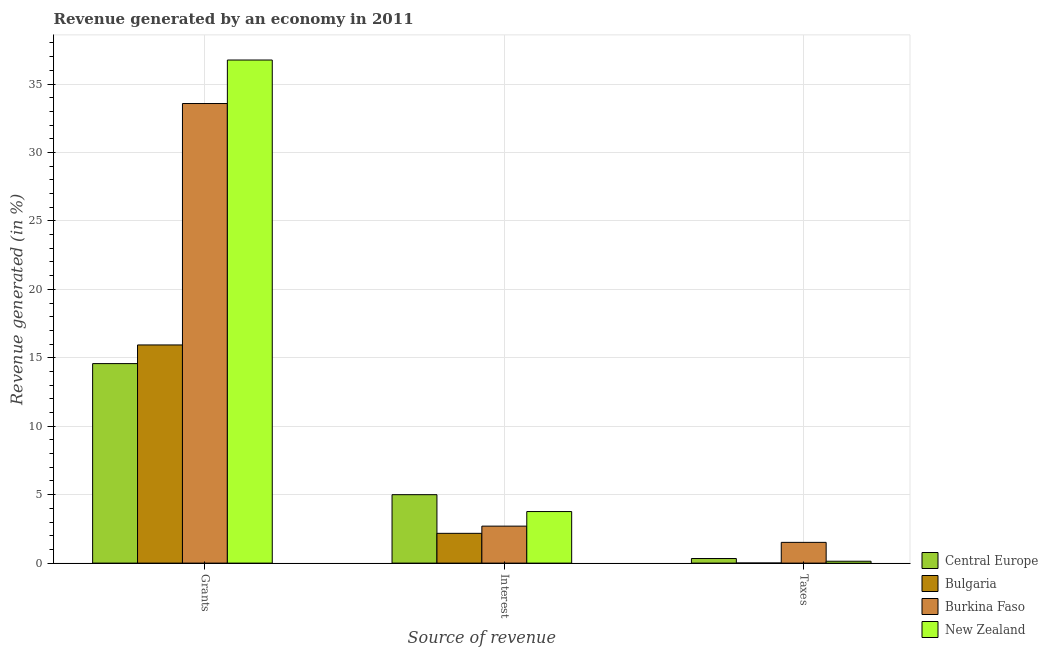How many different coloured bars are there?
Your answer should be very brief. 4. Are the number of bars per tick equal to the number of legend labels?
Your answer should be very brief. Yes. How many bars are there on the 2nd tick from the right?
Provide a short and direct response. 4. What is the label of the 2nd group of bars from the left?
Your answer should be compact. Interest. What is the percentage of revenue generated by interest in Burkina Faso?
Keep it short and to the point. 2.7. Across all countries, what is the maximum percentage of revenue generated by taxes?
Offer a very short reply. 1.52. Across all countries, what is the minimum percentage of revenue generated by grants?
Provide a short and direct response. 14.58. In which country was the percentage of revenue generated by grants maximum?
Your answer should be compact. New Zealand. In which country was the percentage of revenue generated by grants minimum?
Keep it short and to the point. Central Europe. What is the total percentage of revenue generated by grants in the graph?
Keep it short and to the point. 100.85. What is the difference between the percentage of revenue generated by interest in New Zealand and that in Central Europe?
Provide a short and direct response. -1.23. What is the difference between the percentage of revenue generated by grants in Burkina Faso and the percentage of revenue generated by interest in Central Europe?
Ensure brevity in your answer.  28.58. What is the average percentage of revenue generated by grants per country?
Offer a terse response. 25.21. What is the difference between the percentage of revenue generated by taxes and percentage of revenue generated by grants in Central Europe?
Your response must be concise. -14.24. In how many countries, is the percentage of revenue generated by grants greater than 16 %?
Keep it short and to the point. 2. What is the ratio of the percentage of revenue generated by grants in Central Europe to that in Burkina Faso?
Keep it short and to the point. 0.43. What is the difference between the highest and the second highest percentage of revenue generated by grants?
Offer a terse response. 3.18. What is the difference between the highest and the lowest percentage of revenue generated by grants?
Your answer should be compact. 22.18. Is the sum of the percentage of revenue generated by interest in New Zealand and Burkina Faso greater than the maximum percentage of revenue generated by grants across all countries?
Offer a terse response. No. What does the 2nd bar from the left in Interest represents?
Offer a very short reply. Bulgaria. What does the 1st bar from the right in Grants represents?
Your response must be concise. New Zealand. Is it the case that in every country, the sum of the percentage of revenue generated by grants and percentage of revenue generated by interest is greater than the percentage of revenue generated by taxes?
Make the answer very short. Yes. How many bars are there?
Ensure brevity in your answer.  12. Are all the bars in the graph horizontal?
Make the answer very short. No. How many countries are there in the graph?
Make the answer very short. 4. What is the difference between two consecutive major ticks on the Y-axis?
Your response must be concise. 5. Does the graph contain any zero values?
Your answer should be compact. No. Where does the legend appear in the graph?
Offer a very short reply. Bottom right. How are the legend labels stacked?
Keep it short and to the point. Vertical. What is the title of the graph?
Make the answer very short. Revenue generated by an economy in 2011. Does "High income: OECD" appear as one of the legend labels in the graph?
Offer a terse response. No. What is the label or title of the X-axis?
Make the answer very short. Source of revenue. What is the label or title of the Y-axis?
Your answer should be very brief. Revenue generated (in %). What is the Revenue generated (in %) of Central Europe in Grants?
Your answer should be very brief. 14.58. What is the Revenue generated (in %) of Bulgaria in Grants?
Make the answer very short. 15.94. What is the Revenue generated (in %) in Burkina Faso in Grants?
Your answer should be compact. 33.58. What is the Revenue generated (in %) in New Zealand in Grants?
Keep it short and to the point. 36.76. What is the Revenue generated (in %) of Central Europe in Interest?
Your answer should be compact. 5. What is the Revenue generated (in %) of Bulgaria in Interest?
Ensure brevity in your answer.  2.18. What is the Revenue generated (in %) in Burkina Faso in Interest?
Provide a short and direct response. 2.7. What is the Revenue generated (in %) of New Zealand in Interest?
Your answer should be very brief. 3.77. What is the Revenue generated (in %) in Central Europe in Taxes?
Provide a succinct answer. 0.34. What is the Revenue generated (in %) of Bulgaria in Taxes?
Provide a short and direct response. 0.01. What is the Revenue generated (in %) of Burkina Faso in Taxes?
Your answer should be compact. 1.52. What is the Revenue generated (in %) in New Zealand in Taxes?
Your response must be concise. 0.14. Across all Source of revenue, what is the maximum Revenue generated (in %) in Central Europe?
Your answer should be compact. 14.58. Across all Source of revenue, what is the maximum Revenue generated (in %) of Bulgaria?
Make the answer very short. 15.94. Across all Source of revenue, what is the maximum Revenue generated (in %) of Burkina Faso?
Ensure brevity in your answer.  33.58. Across all Source of revenue, what is the maximum Revenue generated (in %) of New Zealand?
Provide a short and direct response. 36.76. Across all Source of revenue, what is the minimum Revenue generated (in %) of Central Europe?
Provide a succinct answer. 0.34. Across all Source of revenue, what is the minimum Revenue generated (in %) in Bulgaria?
Keep it short and to the point. 0.01. Across all Source of revenue, what is the minimum Revenue generated (in %) of Burkina Faso?
Provide a short and direct response. 1.52. Across all Source of revenue, what is the minimum Revenue generated (in %) in New Zealand?
Offer a terse response. 0.14. What is the total Revenue generated (in %) in Central Europe in the graph?
Give a very brief answer. 19.91. What is the total Revenue generated (in %) in Bulgaria in the graph?
Your answer should be very brief. 18.12. What is the total Revenue generated (in %) in Burkina Faso in the graph?
Offer a terse response. 37.79. What is the total Revenue generated (in %) in New Zealand in the graph?
Make the answer very short. 40.66. What is the difference between the Revenue generated (in %) of Central Europe in Grants and that in Interest?
Give a very brief answer. 9.58. What is the difference between the Revenue generated (in %) of Bulgaria in Grants and that in Interest?
Offer a terse response. 13.76. What is the difference between the Revenue generated (in %) in Burkina Faso in Grants and that in Interest?
Provide a succinct answer. 30.88. What is the difference between the Revenue generated (in %) in New Zealand in Grants and that in Interest?
Offer a terse response. 32.99. What is the difference between the Revenue generated (in %) of Central Europe in Grants and that in Taxes?
Keep it short and to the point. 14.24. What is the difference between the Revenue generated (in %) of Bulgaria in Grants and that in Taxes?
Your answer should be compact. 15.93. What is the difference between the Revenue generated (in %) of Burkina Faso in Grants and that in Taxes?
Provide a succinct answer. 32.06. What is the difference between the Revenue generated (in %) in New Zealand in Grants and that in Taxes?
Your response must be concise. 36.62. What is the difference between the Revenue generated (in %) in Central Europe in Interest and that in Taxes?
Provide a short and direct response. 4.66. What is the difference between the Revenue generated (in %) in Bulgaria in Interest and that in Taxes?
Your answer should be very brief. 2.17. What is the difference between the Revenue generated (in %) in Burkina Faso in Interest and that in Taxes?
Offer a very short reply. 1.19. What is the difference between the Revenue generated (in %) in New Zealand in Interest and that in Taxes?
Your answer should be compact. 3.63. What is the difference between the Revenue generated (in %) in Central Europe in Grants and the Revenue generated (in %) in Bulgaria in Interest?
Your answer should be very brief. 12.4. What is the difference between the Revenue generated (in %) in Central Europe in Grants and the Revenue generated (in %) in Burkina Faso in Interest?
Keep it short and to the point. 11.88. What is the difference between the Revenue generated (in %) in Central Europe in Grants and the Revenue generated (in %) in New Zealand in Interest?
Provide a succinct answer. 10.81. What is the difference between the Revenue generated (in %) of Bulgaria in Grants and the Revenue generated (in %) of Burkina Faso in Interest?
Ensure brevity in your answer.  13.24. What is the difference between the Revenue generated (in %) in Bulgaria in Grants and the Revenue generated (in %) in New Zealand in Interest?
Make the answer very short. 12.17. What is the difference between the Revenue generated (in %) in Burkina Faso in Grants and the Revenue generated (in %) in New Zealand in Interest?
Your answer should be very brief. 29.81. What is the difference between the Revenue generated (in %) in Central Europe in Grants and the Revenue generated (in %) in Bulgaria in Taxes?
Make the answer very short. 14.57. What is the difference between the Revenue generated (in %) in Central Europe in Grants and the Revenue generated (in %) in Burkina Faso in Taxes?
Your answer should be very brief. 13.06. What is the difference between the Revenue generated (in %) in Central Europe in Grants and the Revenue generated (in %) in New Zealand in Taxes?
Provide a short and direct response. 14.44. What is the difference between the Revenue generated (in %) of Bulgaria in Grants and the Revenue generated (in %) of Burkina Faso in Taxes?
Provide a short and direct response. 14.42. What is the difference between the Revenue generated (in %) of Bulgaria in Grants and the Revenue generated (in %) of New Zealand in Taxes?
Your answer should be very brief. 15.8. What is the difference between the Revenue generated (in %) in Burkina Faso in Grants and the Revenue generated (in %) in New Zealand in Taxes?
Keep it short and to the point. 33.44. What is the difference between the Revenue generated (in %) in Central Europe in Interest and the Revenue generated (in %) in Bulgaria in Taxes?
Your answer should be very brief. 4.99. What is the difference between the Revenue generated (in %) in Central Europe in Interest and the Revenue generated (in %) in Burkina Faso in Taxes?
Offer a terse response. 3.48. What is the difference between the Revenue generated (in %) in Central Europe in Interest and the Revenue generated (in %) in New Zealand in Taxes?
Your response must be concise. 4.86. What is the difference between the Revenue generated (in %) in Bulgaria in Interest and the Revenue generated (in %) in Burkina Faso in Taxes?
Your response must be concise. 0.66. What is the difference between the Revenue generated (in %) in Bulgaria in Interest and the Revenue generated (in %) in New Zealand in Taxes?
Ensure brevity in your answer.  2.04. What is the difference between the Revenue generated (in %) of Burkina Faso in Interest and the Revenue generated (in %) of New Zealand in Taxes?
Give a very brief answer. 2.56. What is the average Revenue generated (in %) in Central Europe per Source of revenue?
Offer a terse response. 6.64. What is the average Revenue generated (in %) of Bulgaria per Source of revenue?
Provide a succinct answer. 6.04. What is the average Revenue generated (in %) of Burkina Faso per Source of revenue?
Provide a short and direct response. 12.6. What is the average Revenue generated (in %) of New Zealand per Source of revenue?
Your answer should be very brief. 13.55. What is the difference between the Revenue generated (in %) in Central Europe and Revenue generated (in %) in Bulgaria in Grants?
Make the answer very short. -1.36. What is the difference between the Revenue generated (in %) in Central Europe and Revenue generated (in %) in Burkina Faso in Grants?
Offer a terse response. -19. What is the difference between the Revenue generated (in %) of Central Europe and Revenue generated (in %) of New Zealand in Grants?
Your response must be concise. -22.18. What is the difference between the Revenue generated (in %) of Bulgaria and Revenue generated (in %) of Burkina Faso in Grants?
Your response must be concise. -17.64. What is the difference between the Revenue generated (in %) in Bulgaria and Revenue generated (in %) in New Zealand in Grants?
Offer a very short reply. -20.82. What is the difference between the Revenue generated (in %) of Burkina Faso and Revenue generated (in %) of New Zealand in Grants?
Give a very brief answer. -3.18. What is the difference between the Revenue generated (in %) in Central Europe and Revenue generated (in %) in Bulgaria in Interest?
Give a very brief answer. 2.82. What is the difference between the Revenue generated (in %) in Central Europe and Revenue generated (in %) in Burkina Faso in Interest?
Keep it short and to the point. 2.3. What is the difference between the Revenue generated (in %) in Central Europe and Revenue generated (in %) in New Zealand in Interest?
Provide a short and direct response. 1.23. What is the difference between the Revenue generated (in %) of Bulgaria and Revenue generated (in %) of Burkina Faso in Interest?
Make the answer very short. -0.53. What is the difference between the Revenue generated (in %) of Bulgaria and Revenue generated (in %) of New Zealand in Interest?
Offer a terse response. -1.59. What is the difference between the Revenue generated (in %) of Burkina Faso and Revenue generated (in %) of New Zealand in Interest?
Your response must be concise. -1.07. What is the difference between the Revenue generated (in %) of Central Europe and Revenue generated (in %) of Bulgaria in Taxes?
Give a very brief answer. 0.33. What is the difference between the Revenue generated (in %) of Central Europe and Revenue generated (in %) of Burkina Faso in Taxes?
Provide a short and direct response. -1.18. What is the difference between the Revenue generated (in %) of Central Europe and Revenue generated (in %) of New Zealand in Taxes?
Provide a succinct answer. 0.2. What is the difference between the Revenue generated (in %) of Bulgaria and Revenue generated (in %) of Burkina Faso in Taxes?
Offer a very short reply. -1.51. What is the difference between the Revenue generated (in %) in Bulgaria and Revenue generated (in %) in New Zealand in Taxes?
Give a very brief answer. -0.13. What is the difference between the Revenue generated (in %) in Burkina Faso and Revenue generated (in %) in New Zealand in Taxes?
Keep it short and to the point. 1.38. What is the ratio of the Revenue generated (in %) of Central Europe in Grants to that in Interest?
Your response must be concise. 2.92. What is the ratio of the Revenue generated (in %) of Bulgaria in Grants to that in Interest?
Your answer should be compact. 7.33. What is the ratio of the Revenue generated (in %) of Burkina Faso in Grants to that in Interest?
Ensure brevity in your answer.  12.43. What is the ratio of the Revenue generated (in %) of New Zealand in Grants to that in Interest?
Make the answer very short. 9.76. What is the ratio of the Revenue generated (in %) of Central Europe in Grants to that in Taxes?
Provide a short and direct response. 43.42. What is the ratio of the Revenue generated (in %) of Bulgaria in Grants to that in Taxes?
Provide a succinct answer. 2212.43. What is the ratio of the Revenue generated (in %) of Burkina Faso in Grants to that in Taxes?
Keep it short and to the point. 22.16. What is the ratio of the Revenue generated (in %) in New Zealand in Grants to that in Taxes?
Provide a short and direct response. 267.59. What is the ratio of the Revenue generated (in %) in Central Europe in Interest to that in Taxes?
Your response must be concise. 14.89. What is the ratio of the Revenue generated (in %) of Bulgaria in Interest to that in Taxes?
Provide a short and direct response. 301.99. What is the ratio of the Revenue generated (in %) in Burkina Faso in Interest to that in Taxes?
Keep it short and to the point. 1.78. What is the ratio of the Revenue generated (in %) in New Zealand in Interest to that in Taxes?
Make the answer very short. 27.43. What is the difference between the highest and the second highest Revenue generated (in %) in Central Europe?
Your answer should be very brief. 9.58. What is the difference between the highest and the second highest Revenue generated (in %) in Bulgaria?
Keep it short and to the point. 13.76. What is the difference between the highest and the second highest Revenue generated (in %) in Burkina Faso?
Keep it short and to the point. 30.88. What is the difference between the highest and the second highest Revenue generated (in %) of New Zealand?
Make the answer very short. 32.99. What is the difference between the highest and the lowest Revenue generated (in %) of Central Europe?
Keep it short and to the point. 14.24. What is the difference between the highest and the lowest Revenue generated (in %) in Bulgaria?
Offer a terse response. 15.93. What is the difference between the highest and the lowest Revenue generated (in %) in Burkina Faso?
Offer a very short reply. 32.06. What is the difference between the highest and the lowest Revenue generated (in %) of New Zealand?
Keep it short and to the point. 36.62. 